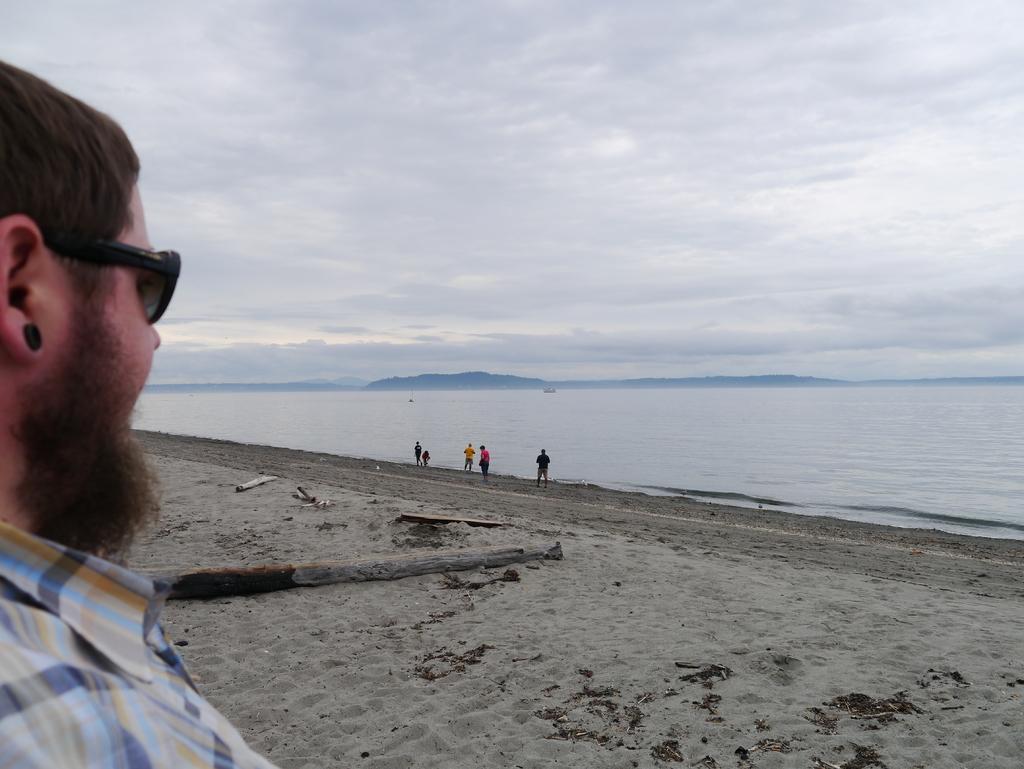Could you give a brief overview of what you see in this image? This is the man standing. He wore goggles, an earring and a shirt. This looks like a seashore. I can see few people standing. This is the water flowing. In the background, that looks like a hill. I think this is the tree trunk. 